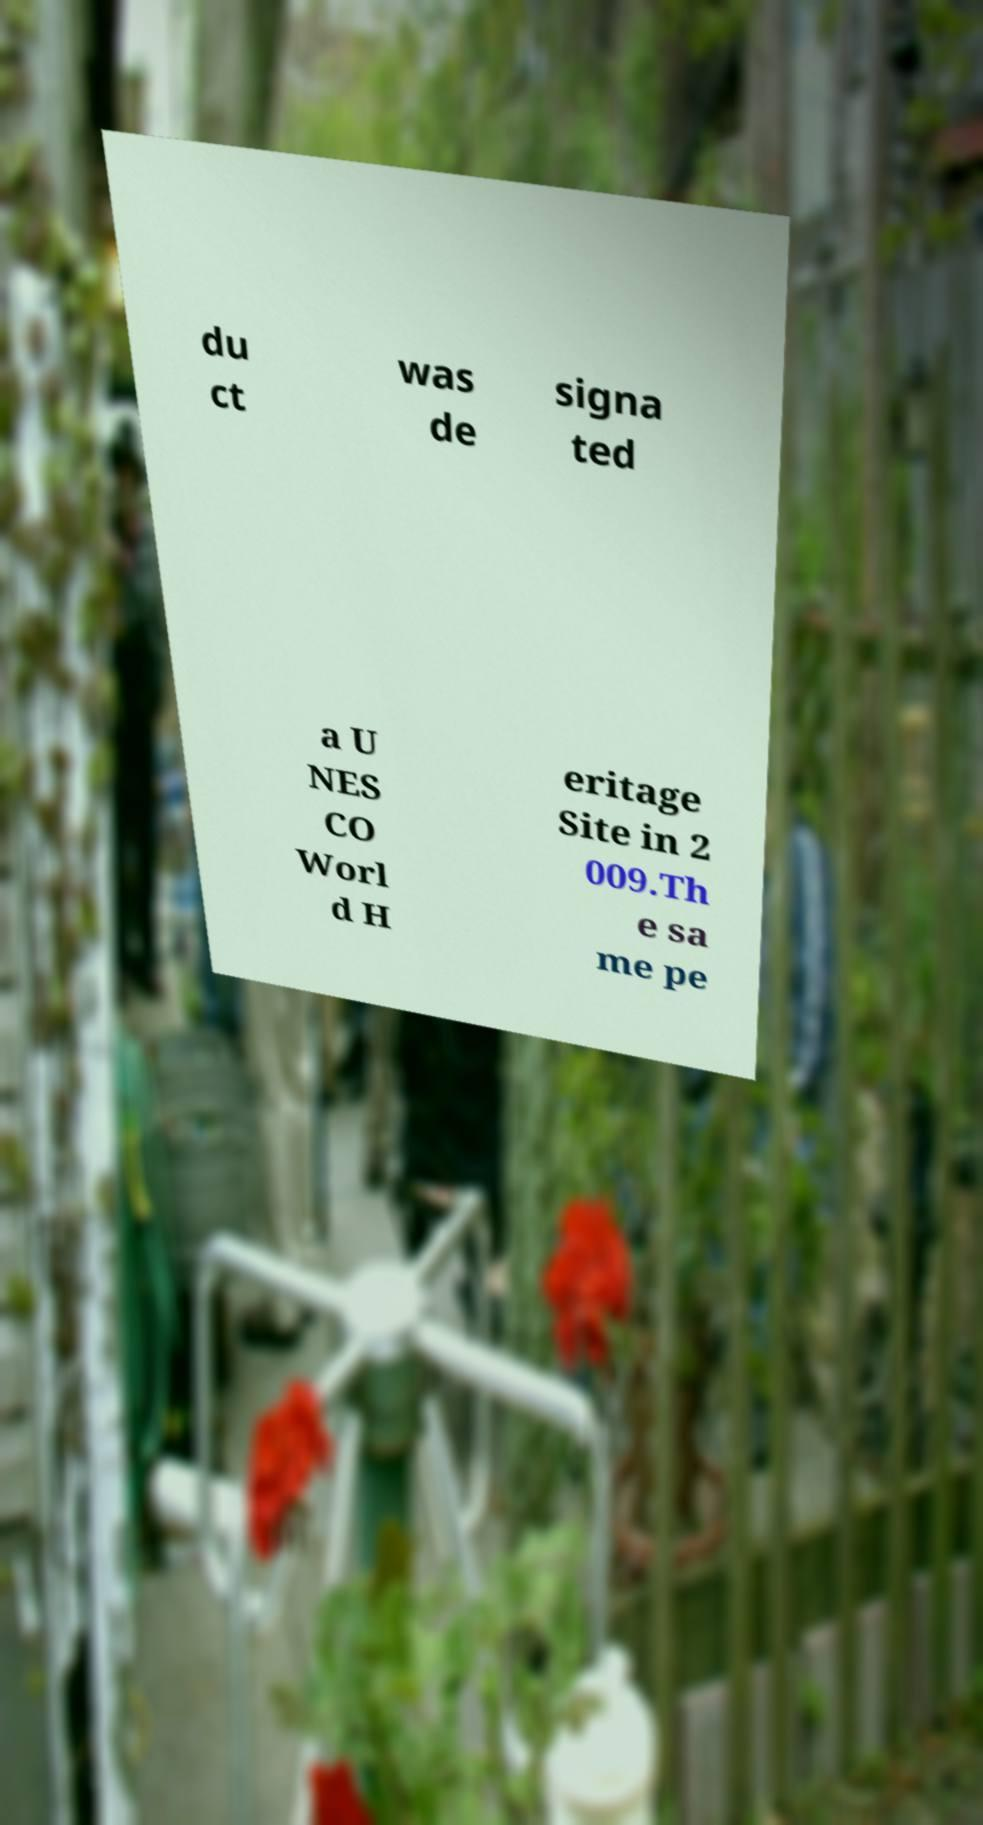Could you extract and type out the text from this image? du ct was de signa ted a U NES CO Worl d H eritage Site in 2 009.Th e sa me pe 